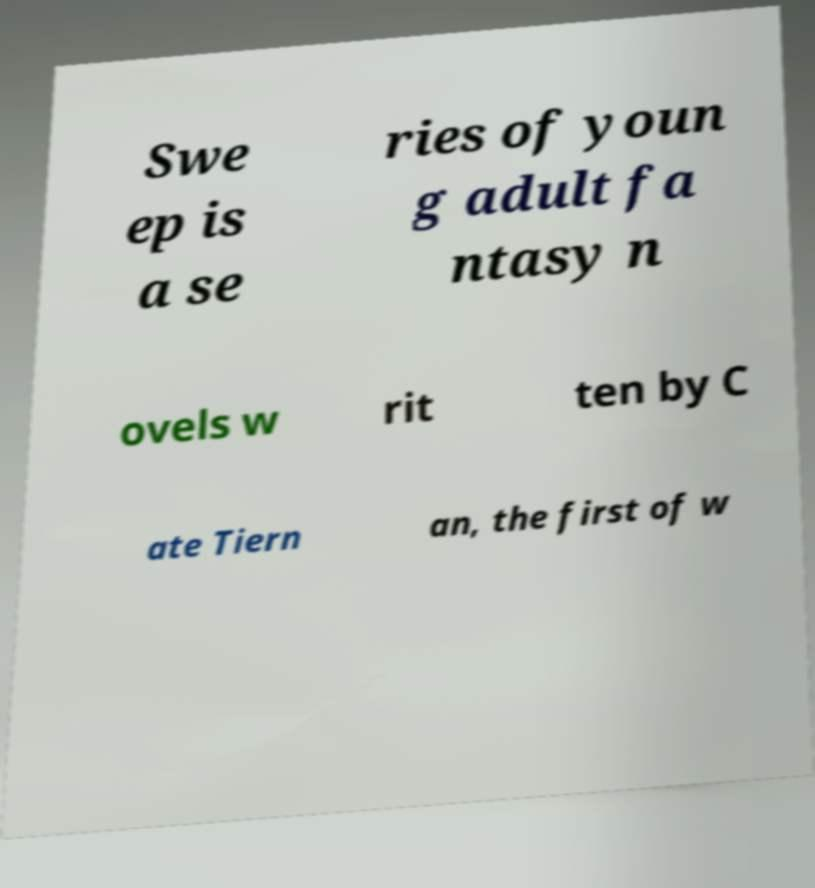I need the written content from this picture converted into text. Can you do that? Swe ep is a se ries of youn g adult fa ntasy n ovels w rit ten by C ate Tiern an, the first of w 